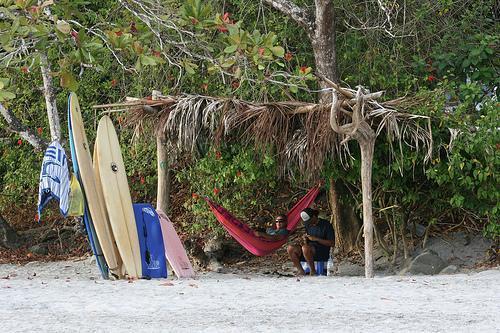How many people are there?
Give a very brief answer. 1. 